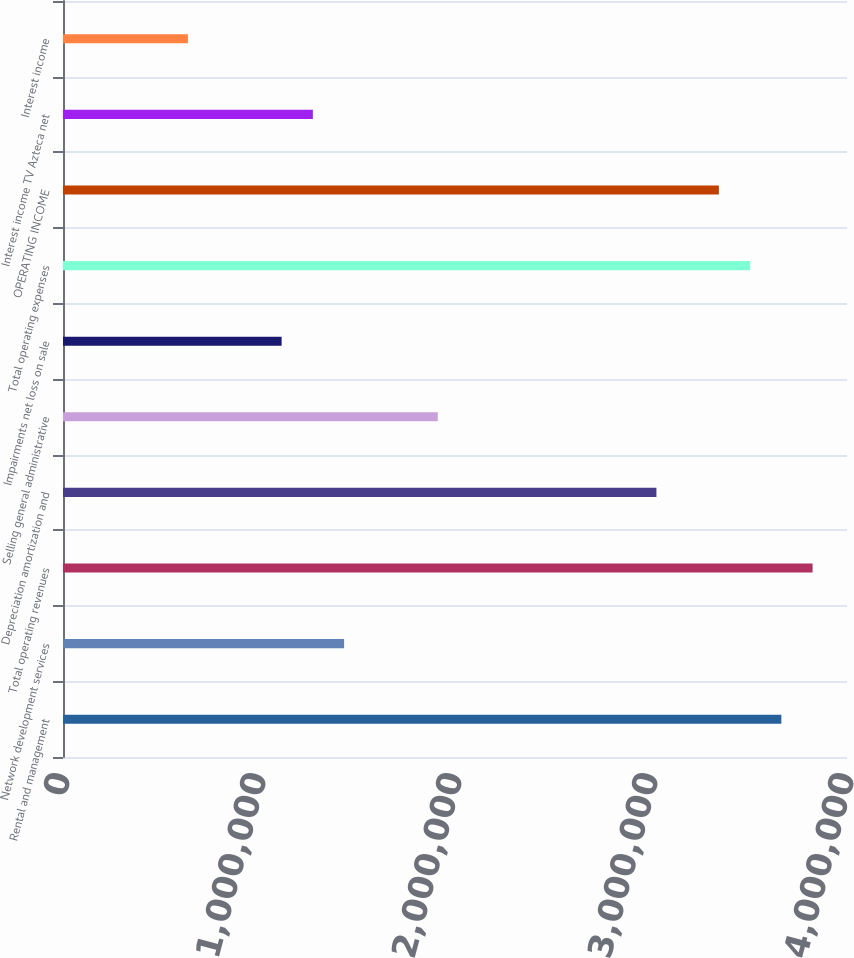Convert chart. <chart><loc_0><loc_0><loc_500><loc_500><bar_chart><fcel>Rental and management<fcel>Network development services<fcel>Total operating revenues<fcel>Depreciation amortization and<fcel>Selling general administrative<fcel>Impairments net loss on sale<fcel>Total operating expenses<fcel>OPERATING INCOME<fcel>Interest income TV Azteca net<fcel>Interest income<nl><fcel>3.66506e+06<fcel>1.43415e+06<fcel>3.82441e+06<fcel>3.02766e+06<fcel>1.9122e+06<fcel>1.11545e+06<fcel>3.50571e+06<fcel>3.34636e+06<fcel>1.2748e+06<fcel>637402<nl></chart> 